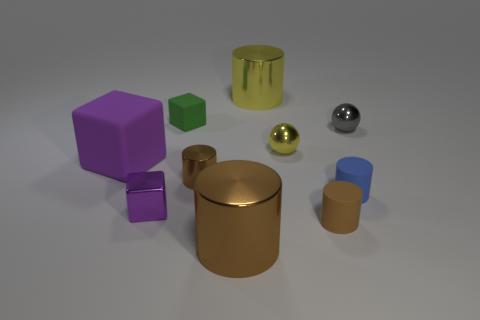The purple rubber object is what size?
Your response must be concise. Large. Is the number of tiny green matte things less than the number of small cyan cylinders?
Provide a short and direct response. No. There is a large shiny cylinder that is behind the brown object that is on the right side of the big yellow shiny cylinder; what is its color?
Provide a succinct answer. Yellow. What is the small brown cylinder that is on the left side of the large cylinder behind the shiny ball that is in front of the gray ball made of?
Keep it short and to the point. Metal. There is a cylinder that is behind the gray sphere; is it the same size as the purple matte block?
Provide a short and direct response. Yes. There is a tiny cylinder that is on the right side of the brown rubber thing; what is its material?
Your response must be concise. Rubber. Are there more rubber objects than cylinders?
Ensure brevity in your answer.  No. How many things are large cylinders that are behind the small gray object or tiny blue shiny balls?
Offer a very short reply. 1. There is a small matte cylinder behind the brown rubber cylinder; what number of green matte objects are to the right of it?
Make the answer very short. 0. There is a metal cylinder that is to the right of the big shiny cylinder that is in front of the tiny sphere that is behind the small yellow thing; what is its size?
Ensure brevity in your answer.  Large. 